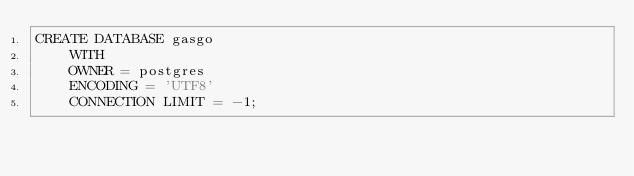Convert code to text. <code><loc_0><loc_0><loc_500><loc_500><_SQL_>CREATE DATABASE gasgo
    WITH 
    OWNER = postgres
    ENCODING = 'UTF8'
    CONNECTION LIMIT = -1;</code> 